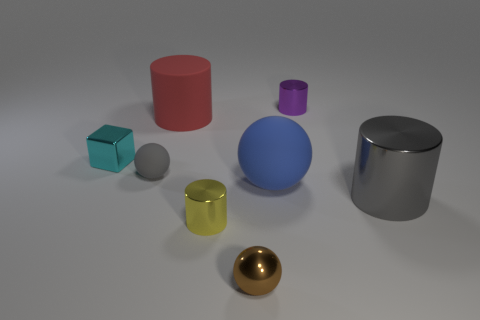What number of objects are large rubber things on the right side of the metallic ball or big yellow shiny blocks?
Your answer should be very brief. 1. There is a thing to the right of the tiny purple metal cylinder; how big is it?
Offer a very short reply. Large. What material is the cyan block?
Your answer should be very brief. Metal. What shape is the gray object that is behind the big object to the right of the blue thing?
Your answer should be compact. Sphere. How many other objects are the same shape as the red object?
Offer a terse response. 3. There is a small purple metallic thing; are there any tiny yellow cylinders on the left side of it?
Your answer should be very brief. Yes. The small matte thing is what color?
Your response must be concise. Gray. There is a large shiny cylinder; does it have the same color as the tiny object that is on the left side of the tiny gray thing?
Provide a succinct answer. No. Is there a gray metal cylinder of the same size as the brown sphere?
Provide a succinct answer. No. The metallic cylinder that is the same color as the small rubber thing is what size?
Your answer should be very brief. Large. 